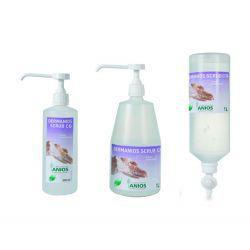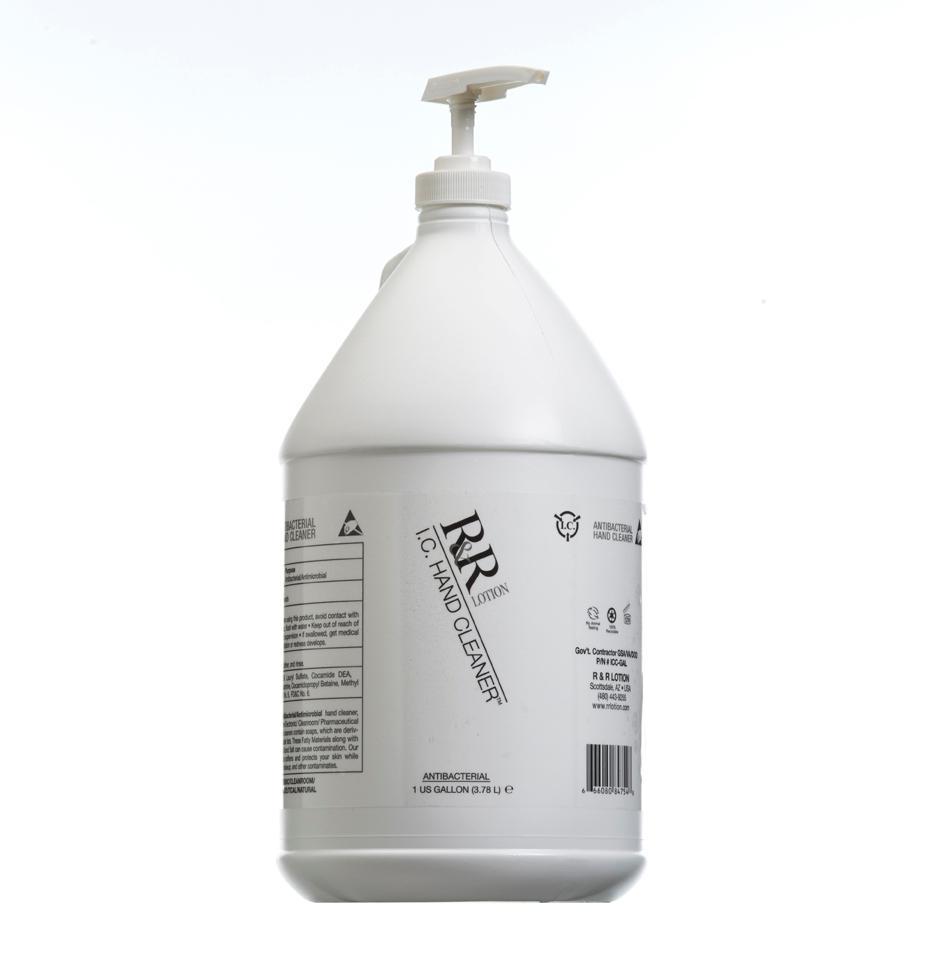The first image is the image on the left, the second image is the image on the right. Assess this claim about the two images: "There are two yellow bottles of lotion". Correct or not? Answer yes or no. No. 